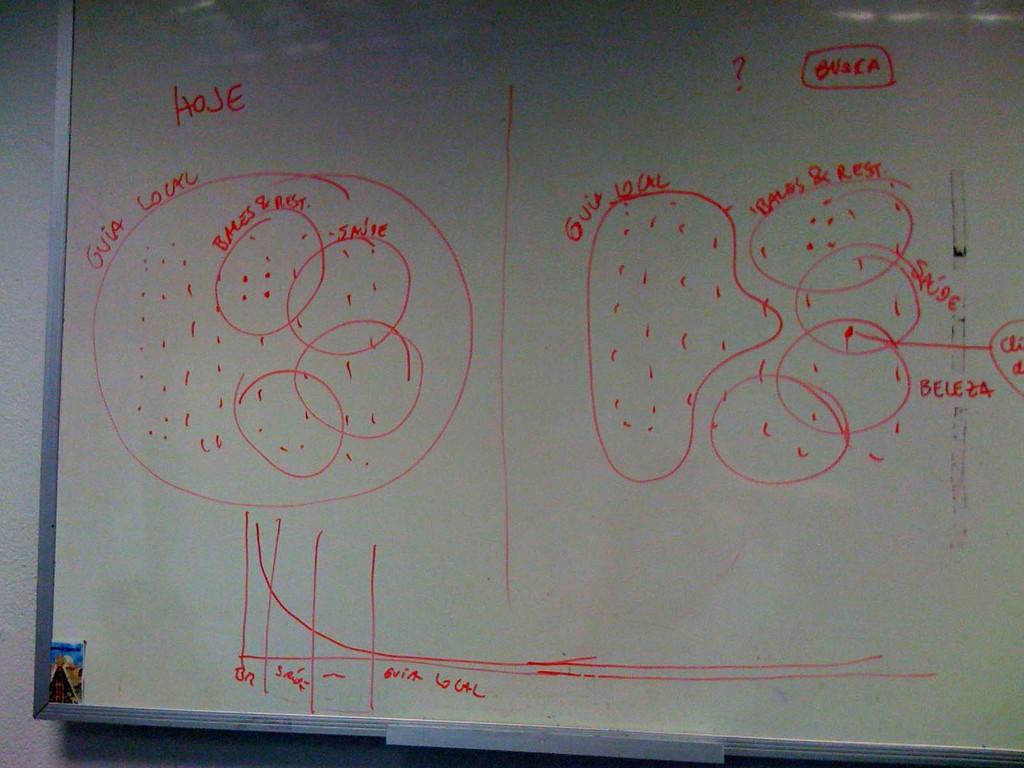Is the text on the board in english?
Provide a succinct answer. No. 